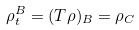<formula> <loc_0><loc_0><loc_500><loc_500>\rho ^ { B } _ { t } = ( T \rho ) _ { B } = \rho _ { C }</formula> 